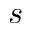<formula> <loc_0><loc_0><loc_500><loc_500>s</formula> 